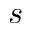<formula> <loc_0><loc_0><loc_500><loc_500>s</formula> 